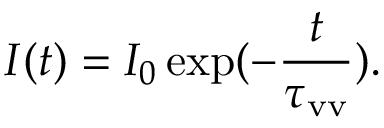<formula> <loc_0><loc_0><loc_500><loc_500>I ( t ) = I _ { 0 } \exp ( - \frac { t } { \tau _ { v v } } ) .</formula> 